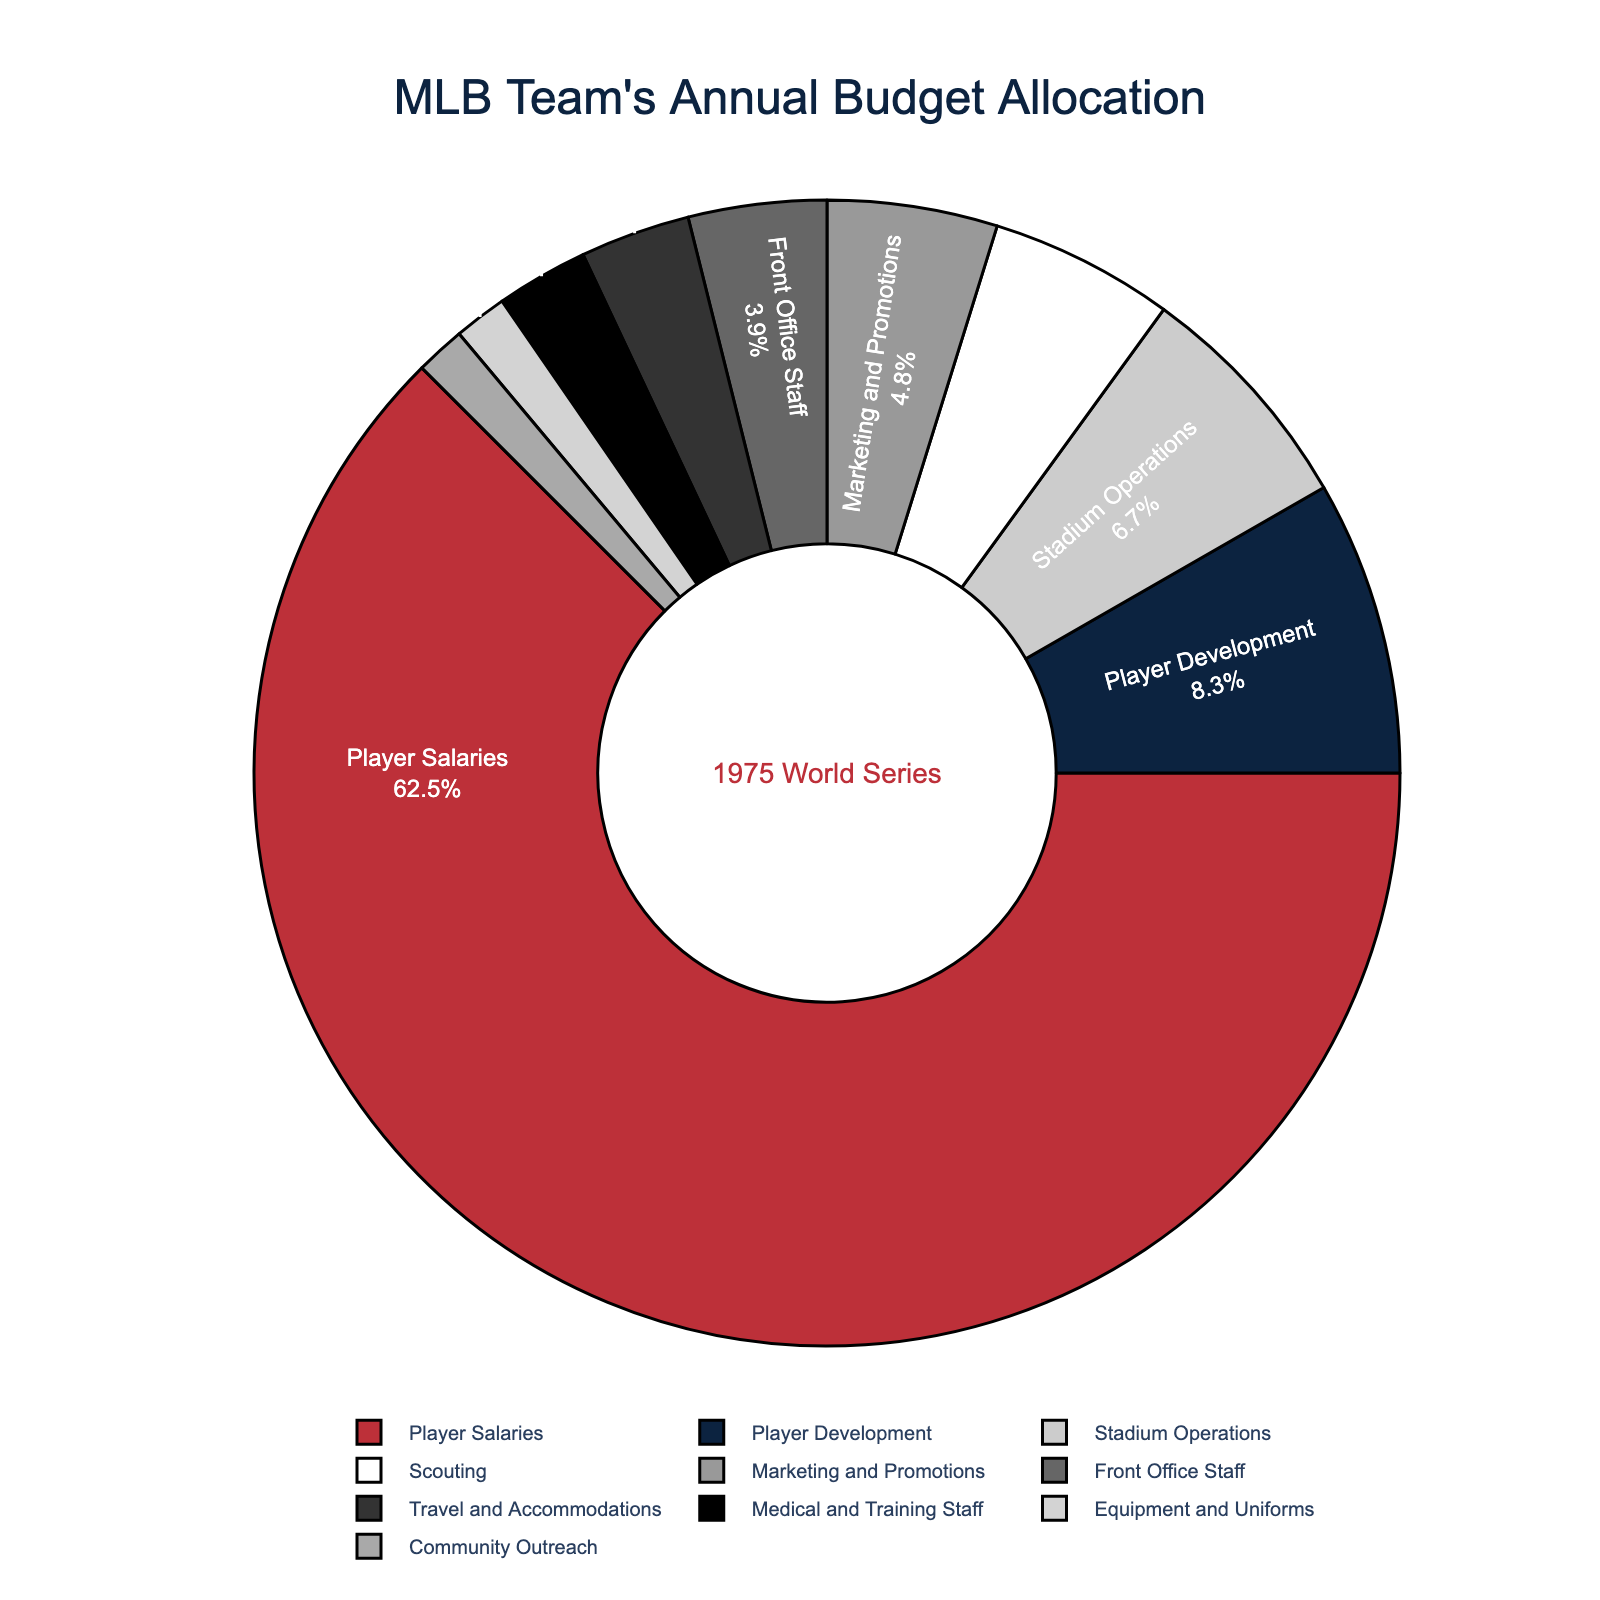What percentage of the budget is allocated to scouting and medical and training staff combined? Add the percentages allocated to scouting (5.2%) and medical and training staff (2.6%). 5.2% + 2.6% = 7.8%
Answer: 7.8% Which department receives the largest portion of the budget? The largest slice in the pie chart represents the department with the highest percentage. Player Salaries is the largest with 62.5%.
Answer: Player Salaries Which department has the smallest budget allocation, and what is the percentage? The smallest slice in the pie chart represents the department with the lowest percentage, which is Community Outreach with 1.4%.
Answer: Community Outreach, 1.4% Is the percentage allocated to marketing and promotions greater than the percentage allocated to front office staff? Compare the slices representing marketing and promotions (4.8%) and front office staff (3.9%). 4.8% > 3.9%
Answer: Yes What is the total percentage allocated to player development, scouting, and stadium operations? Add the percentages for player development (8.3%), scouting (5.2%), and stadium operations (6.7%). 8.3% + 5.2% + 6.7% = 20.2%
Answer: 20.2% How does the allocation to travel and accommodations compare to the allocation to equipment and uniforms? Compare the slices for travel and accommodations (3.1%) and equipment and uniforms (1.5%). 3.1% is greater than 1.5%.
Answer: Travel and accommodations has a higher allocation Which department has the second highest budget allocation? Identify the second largest slice after Player Salaries. Player Development has the second highest allocation at 8.3%.
Answer: Player Development How much more is allocated to player salaries than to all other departments combined? Subtract the percentage allocated to player salaries (62.5%) from 100% to get the total allocation for all other departments (37.5%). 62.5% - 37.5% = 25%
Answer: 25% What color is used to represent the marketing and promotions department? Observe the slice color representing marketing and promotions. It is represented by a grey color.
Answer: Grey Is the combined budget for marketing and promotions, front office staff, and community outreach greater than that for stadium operations? Add percentages for marketing and promotions (4.8%), front office staff (3.9%), and community outreach (1.4%) to compare against stadium operations (6.7%). 4.8% + 3.9% + 1.4% = 10.1%, which is greater than 6.7%.
Answer: Yes 